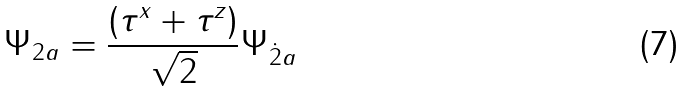Convert formula to latex. <formula><loc_0><loc_0><loc_500><loc_500>\Psi _ { 2 a } = \frac { ( \tau ^ { x } + \tau ^ { z } ) } { \sqrt { 2 } } \Psi _ { \dot { 2 } a }</formula> 